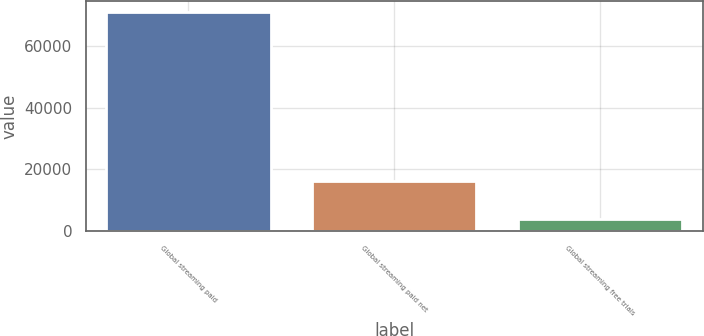<chart> <loc_0><loc_0><loc_500><loc_500><bar_chart><fcel>Global streaming paid<fcel>Global streaming paid net<fcel>Global streaming free trials<nl><fcel>70839<fcel>16363<fcel>3923<nl></chart> 